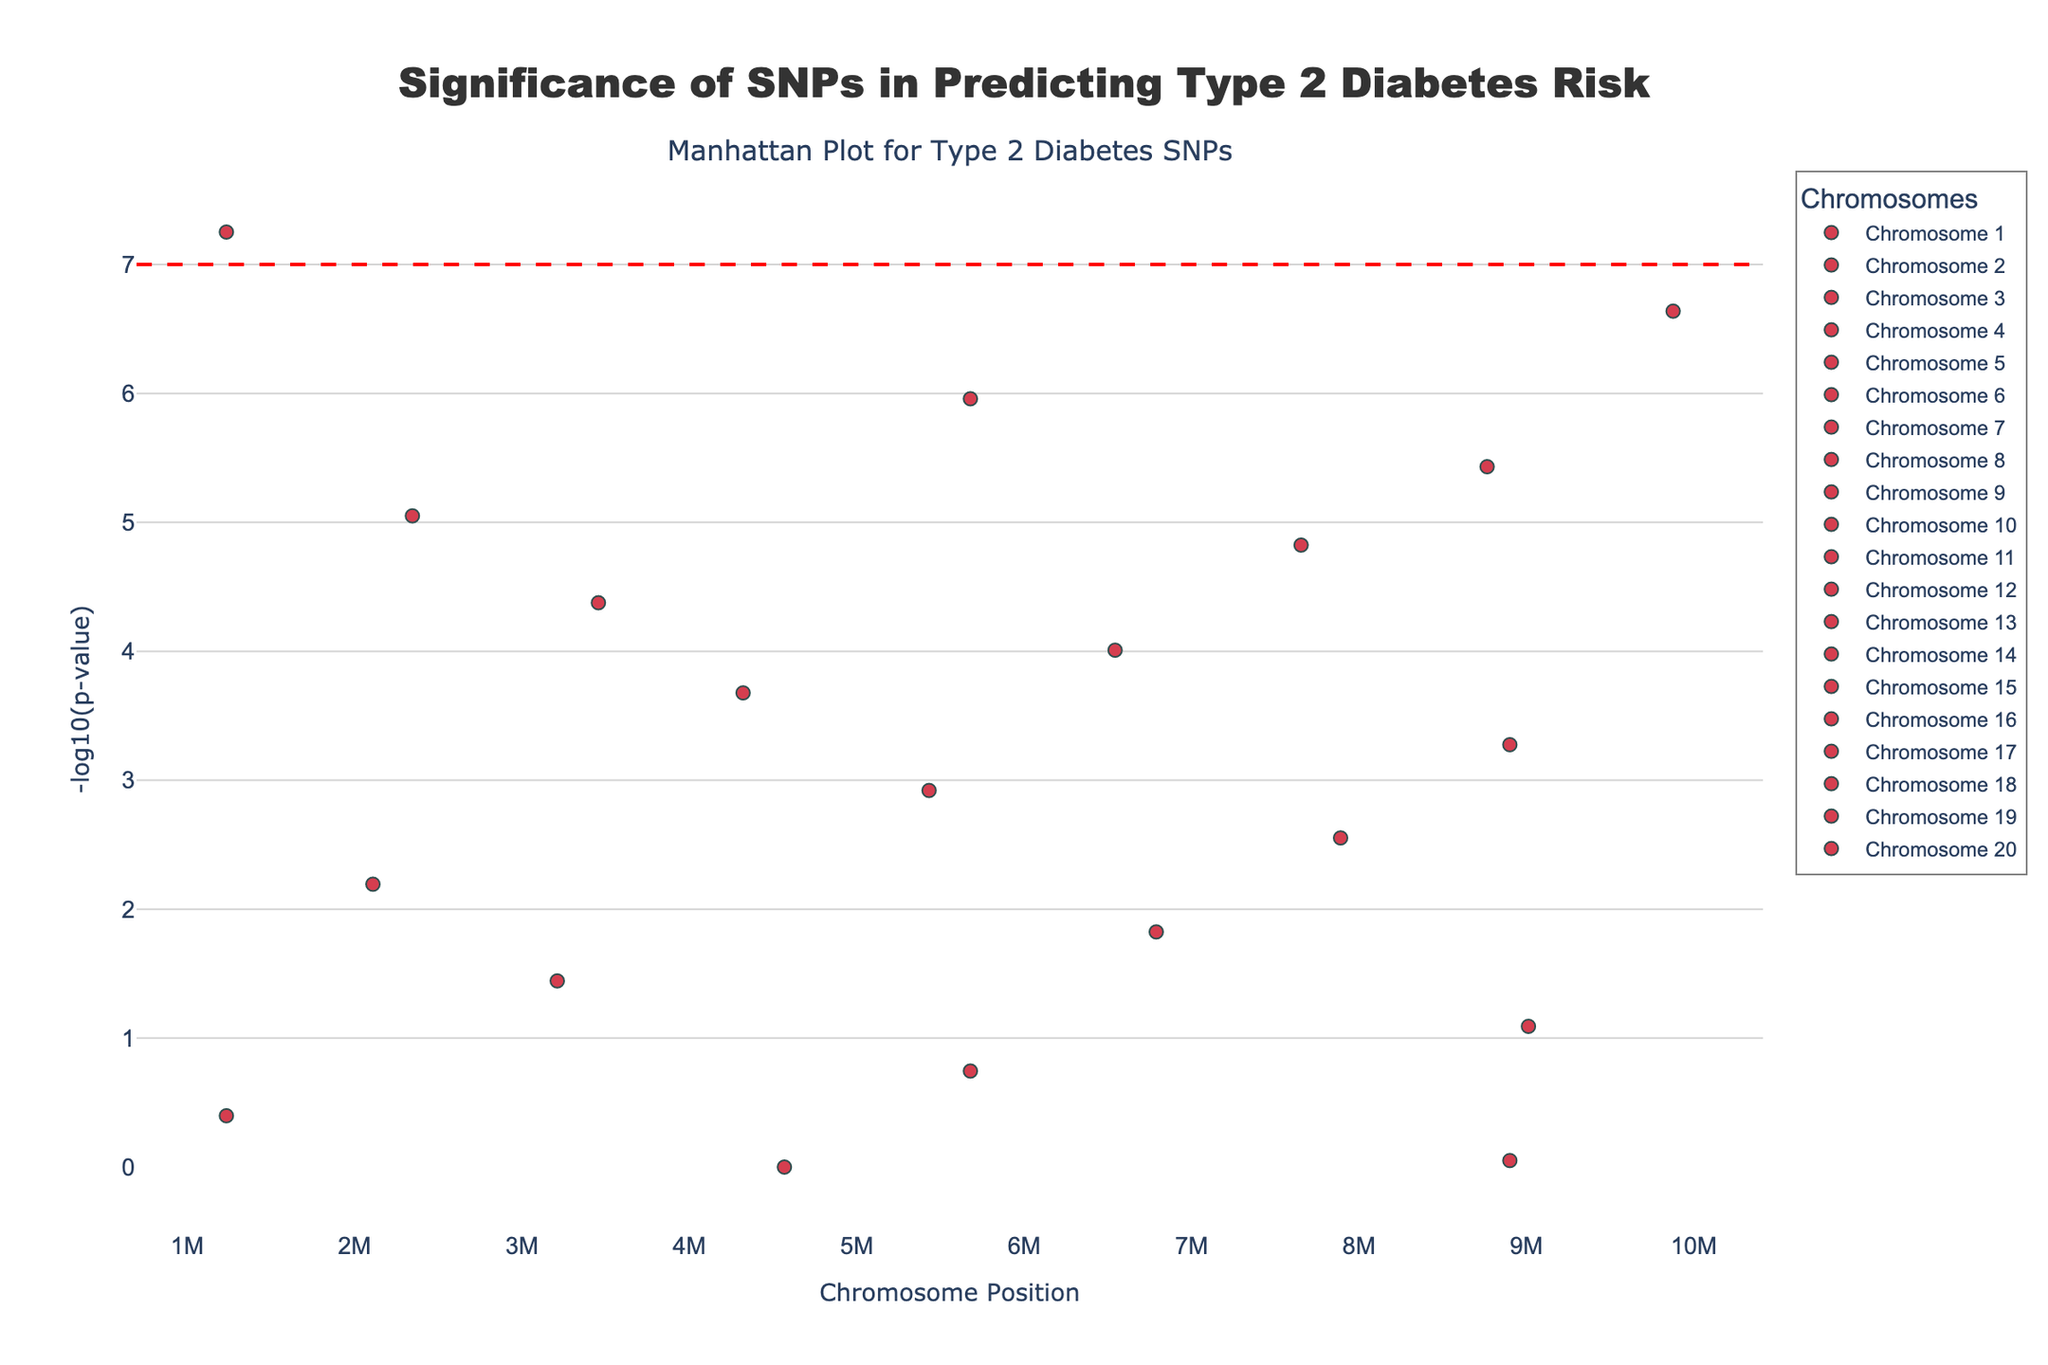What is the title of the plot? The title of the plot is usually at the top center of the figure and is used to summarize the main topic or purpose of the plot.
Answer: Significance of SNPs in Predicting Type 2 Diabetes Risk What does the y-axis represent? The y-axis typically shows the variable being measured or observed, and in a Manhattan plot, it usually represents the significance of the association between SNPs and the trait.
Answer: -log10(p-value) Which SNP has the most significant association with Type 2 Diabetes risk? The SNP with the smallest p-value, which corresponds to the highest -log10(p-value) value on the y-axis, is the most significant.
Answer: rs7903146 How many SNPs have a -log10(p-value) greater than 7? Check the y-axis values and count the data points that have -log10(p-values) above the threshold line at 7.
Answer: 1 Which chromosome has the SNP with the lowest p-value? Identify the SNP with the highest -log10(p-value) and note down which chromosome it is on.
Answer: Chromosome 1 What is the general trend observable in the SNP significance across different chromosomes? Look at the distribution of -log10(p-values) across each chromosome and note any patterns or trends.
Answer: Chromosome 1 has the most significant SNP, and significance generally decreases across higher-numbered chromosomes Compare the significance of SNPs on Chromosome 1 and Chromosome 2. Which chromosomal positions have more significant SNPs? Examine the -log10(p-values) of SNPs on both chromosomes and compare them based on their height.
Answer: Chromosome 1 How many SNPs have a significance (p-value) less than 1e-5? Convert -log10(p-values) back to p-values and count the SNPs with p-values less than 1e-5. For example, -log10(1e-5) = 5, so count all SNPs with values greater than 5 on the y-axis.
Answer: 5 Is there a significance threshold line on the plot, and what does it represent? Note any horizontal lines on the plot and check its position on the y-axis to understand its context, such as p-value thresholds for genome-wide significance.
Answer: Yes, it represents the genome-wide significance threshold at -log10(5e-8) Which SNP's p-value is closest to the general genome-wide significance threshold? Identify the SNP whose -log10(p-value) is closest to but not necessarily above 7.
Answer: rs10885122 